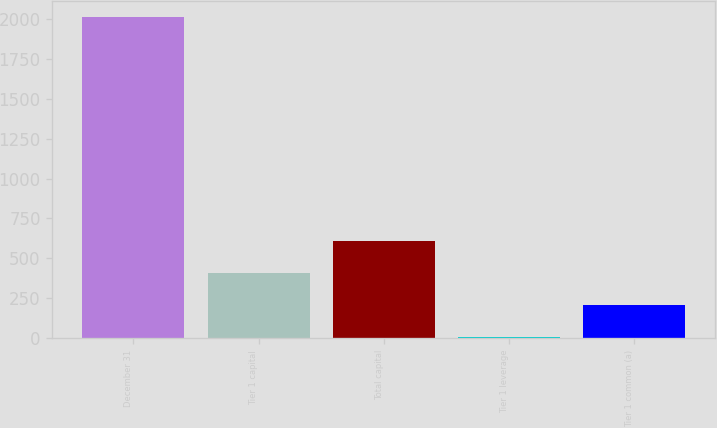Convert chart to OTSL. <chart><loc_0><loc_0><loc_500><loc_500><bar_chart><fcel>December 31<fcel>Tier 1 capital<fcel>Total capital<fcel>Tier 1 leverage<fcel>Tier 1 common (a)<nl><fcel>2013<fcel>408.28<fcel>608.87<fcel>7.1<fcel>207.69<nl></chart> 